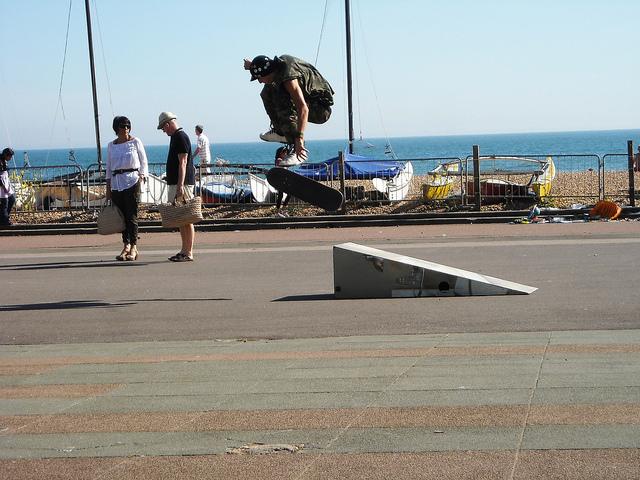What is the ramp for?
Keep it brief. Jumping. What color is the background horizon?
Quick response, please. Blue. Is he going to land?
Write a very short answer. Yes. 